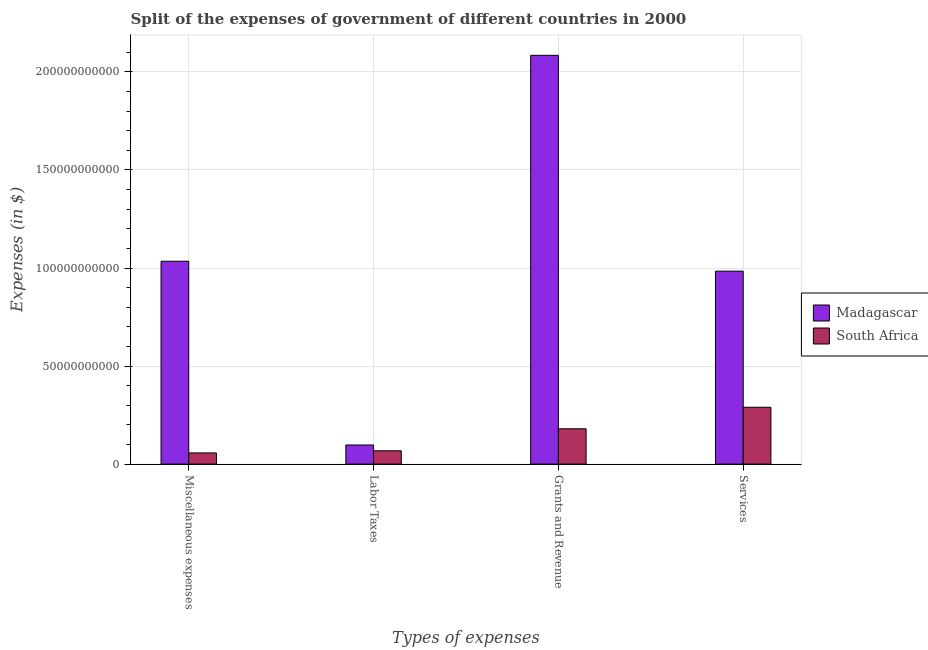How many different coloured bars are there?
Your response must be concise. 2. How many groups of bars are there?
Provide a succinct answer. 4. Are the number of bars on each tick of the X-axis equal?
Offer a terse response. Yes. What is the label of the 2nd group of bars from the left?
Give a very brief answer. Labor Taxes. What is the amount spent on labor taxes in Madagascar?
Your response must be concise. 9.76e+09. Across all countries, what is the maximum amount spent on labor taxes?
Your answer should be compact. 9.76e+09. Across all countries, what is the minimum amount spent on services?
Provide a succinct answer. 2.90e+1. In which country was the amount spent on grants and revenue maximum?
Ensure brevity in your answer.  Madagascar. In which country was the amount spent on labor taxes minimum?
Offer a terse response. South Africa. What is the total amount spent on grants and revenue in the graph?
Your answer should be very brief. 2.26e+11. What is the difference between the amount spent on grants and revenue in Madagascar and that in South Africa?
Make the answer very short. 1.90e+11. What is the difference between the amount spent on grants and revenue in Madagascar and the amount spent on services in South Africa?
Your answer should be very brief. 1.79e+11. What is the average amount spent on grants and revenue per country?
Offer a terse response. 1.13e+11. What is the difference between the amount spent on miscellaneous expenses and amount spent on services in Madagascar?
Your response must be concise. 5.06e+09. In how many countries, is the amount spent on services greater than 110000000000 $?
Make the answer very short. 0. What is the ratio of the amount spent on services in South Africa to that in Madagascar?
Your response must be concise. 0.29. Is the amount spent on services in South Africa less than that in Madagascar?
Your answer should be compact. Yes. Is the difference between the amount spent on services in Madagascar and South Africa greater than the difference between the amount spent on grants and revenue in Madagascar and South Africa?
Your response must be concise. No. What is the difference between the highest and the second highest amount spent on miscellaneous expenses?
Provide a succinct answer. 9.78e+1. What is the difference between the highest and the lowest amount spent on labor taxes?
Your answer should be compact. 2.96e+09. In how many countries, is the amount spent on services greater than the average amount spent on services taken over all countries?
Your response must be concise. 1. What does the 1st bar from the left in Labor Taxes represents?
Give a very brief answer. Madagascar. What does the 1st bar from the right in Services represents?
Offer a very short reply. South Africa. Is it the case that in every country, the sum of the amount spent on miscellaneous expenses and amount spent on labor taxes is greater than the amount spent on grants and revenue?
Ensure brevity in your answer.  No. How many bars are there?
Offer a very short reply. 8. What is the difference between two consecutive major ticks on the Y-axis?
Give a very brief answer. 5.00e+1. Are the values on the major ticks of Y-axis written in scientific E-notation?
Ensure brevity in your answer.  No. Does the graph contain any zero values?
Ensure brevity in your answer.  No. Does the graph contain grids?
Offer a terse response. Yes. Where does the legend appear in the graph?
Provide a succinct answer. Center right. How many legend labels are there?
Offer a terse response. 2. How are the legend labels stacked?
Give a very brief answer. Vertical. What is the title of the graph?
Provide a succinct answer. Split of the expenses of government of different countries in 2000. Does "Botswana" appear as one of the legend labels in the graph?
Provide a succinct answer. No. What is the label or title of the X-axis?
Make the answer very short. Types of expenses. What is the label or title of the Y-axis?
Provide a short and direct response. Expenses (in $). What is the Expenses (in $) in Madagascar in Miscellaneous expenses?
Keep it short and to the point. 1.03e+11. What is the Expenses (in $) of South Africa in Miscellaneous expenses?
Give a very brief answer. 5.70e+09. What is the Expenses (in $) in Madagascar in Labor Taxes?
Your answer should be very brief. 9.76e+09. What is the Expenses (in $) in South Africa in Labor Taxes?
Give a very brief answer. 6.80e+09. What is the Expenses (in $) in Madagascar in Grants and Revenue?
Make the answer very short. 2.08e+11. What is the Expenses (in $) of South Africa in Grants and Revenue?
Provide a short and direct response. 1.80e+1. What is the Expenses (in $) of Madagascar in Services?
Give a very brief answer. 9.84e+1. What is the Expenses (in $) in South Africa in Services?
Make the answer very short. 2.90e+1. Across all Types of expenses, what is the maximum Expenses (in $) of Madagascar?
Your answer should be compact. 2.08e+11. Across all Types of expenses, what is the maximum Expenses (in $) in South Africa?
Offer a terse response. 2.90e+1. Across all Types of expenses, what is the minimum Expenses (in $) of Madagascar?
Ensure brevity in your answer.  9.76e+09. Across all Types of expenses, what is the minimum Expenses (in $) of South Africa?
Give a very brief answer. 5.70e+09. What is the total Expenses (in $) of Madagascar in the graph?
Offer a terse response. 4.20e+11. What is the total Expenses (in $) in South Africa in the graph?
Ensure brevity in your answer.  5.95e+1. What is the difference between the Expenses (in $) of Madagascar in Miscellaneous expenses and that in Labor Taxes?
Your answer should be compact. 9.37e+1. What is the difference between the Expenses (in $) of South Africa in Miscellaneous expenses and that in Labor Taxes?
Offer a very short reply. -1.09e+09. What is the difference between the Expenses (in $) of Madagascar in Miscellaneous expenses and that in Grants and Revenue?
Keep it short and to the point. -1.05e+11. What is the difference between the Expenses (in $) of South Africa in Miscellaneous expenses and that in Grants and Revenue?
Provide a short and direct response. -1.23e+1. What is the difference between the Expenses (in $) of Madagascar in Miscellaneous expenses and that in Services?
Keep it short and to the point. 5.06e+09. What is the difference between the Expenses (in $) in South Africa in Miscellaneous expenses and that in Services?
Make the answer very short. -2.33e+1. What is the difference between the Expenses (in $) in Madagascar in Labor Taxes and that in Grants and Revenue?
Give a very brief answer. -1.99e+11. What is the difference between the Expenses (in $) in South Africa in Labor Taxes and that in Grants and Revenue?
Offer a very short reply. -1.12e+1. What is the difference between the Expenses (in $) in Madagascar in Labor Taxes and that in Services?
Provide a succinct answer. -8.86e+1. What is the difference between the Expenses (in $) of South Africa in Labor Taxes and that in Services?
Your response must be concise. -2.22e+1. What is the difference between the Expenses (in $) in Madagascar in Grants and Revenue and that in Services?
Provide a succinct answer. 1.10e+11. What is the difference between the Expenses (in $) in South Africa in Grants and Revenue and that in Services?
Keep it short and to the point. -1.10e+1. What is the difference between the Expenses (in $) in Madagascar in Miscellaneous expenses and the Expenses (in $) in South Africa in Labor Taxes?
Make the answer very short. 9.67e+1. What is the difference between the Expenses (in $) in Madagascar in Miscellaneous expenses and the Expenses (in $) in South Africa in Grants and Revenue?
Provide a short and direct response. 8.54e+1. What is the difference between the Expenses (in $) in Madagascar in Miscellaneous expenses and the Expenses (in $) in South Africa in Services?
Provide a short and direct response. 7.45e+1. What is the difference between the Expenses (in $) of Madagascar in Labor Taxes and the Expenses (in $) of South Africa in Grants and Revenue?
Offer a very short reply. -8.26e+09. What is the difference between the Expenses (in $) of Madagascar in Labor Taxes and the Expenses (in $) of South Africa in Services?
Your response must be concise. -1.92e+1. What is the difference between the Expenses (in $) of Madagascar in Grants and Revenue and the Expenses (in $) of South Africa in Services?
Give a very brief answer. 1.79e+11. What is the average Expenses (in $) of Madagascar per Types of expenses?
Ensure brevity in your answer.  1.05e+11. What is the average Expenses (in $) of South Africa per Types of expenses?
Your answer should be compact. 1.49e+1. What is the difference between the Expenses (in $) in Madagascar and Expenses (in $) in South Africa in Miscellaneous expenses?
Keep it short and to the point. 9.78e+1. What is the difference between the Expenses (in $) in Madagascar and Expenses (in $) in South Africa in Labor Taxes?
Keep it short and to the point. 2.96e+09. What is the difference between the Expenses (in $) of Madagascar and Expenses (in $) of South Africa in Grants and Revenue?
Offer a very short reply. 1.90e+11. What is the difference between the Expenses (in $) in Madagascar and Expenses (in $) in South Africa in Services?
Give a very brief answer. 6.94e+1. What is the ratio of the Expenses (in $) of Madagascar in Miscellaneous expenses to that in Labor Taxes?
Ensure brevity in your answer.  10.6. What is the ratio of the Expenses (in $) in South Africa in Miscellaneous expenses to that in Labor Taxes?
Make the answer very short. 0.84. What is the ratio of the Expenses (in $) of Madagascar in Miscellaneous expenses to that in Grants and Revenue?
Offer a terse response. 0.5. What is the ratio of the Expenses (in $) of South Africa in Miscellaneous expenses to that in Grants and Revenue?
Keep it short and to the point. 0.32. What is the ratio of the Expenses (in $) in Madagascar in Miscellaneous expenses to that in Services?
Provide a short and direct response. 1.05. What is the ratio of the Expenses (in $) in South Africa in Miscellaneous expenses to that in Services?
Offer a very short reply. 0.2. What is the ratio of the Expenses (in $) of Madagascar in Labor Taxes to that in Grants and Revenue?
Offer a terse response. 0.05. What is the ratio of the Expenses (in $) in South Africa in Labor Taxes to that in Grants and Revenue?
Make the answer very short. 0.38. What is the ratio of the Expenses (in $) in Madagascar in Labor Taxes to that in Services?
Keep it short and to the point. 0.1. What is the ratio of the Expenses (in $) in South Africa in Labor Taxes to that in Services?
Provide a short and direct response. 0.23. What is the ratio of the Expenses (in $) in Madagascar in Grants and Revenue to that in Services?
Provide a short and direct response. 2.12. What is the ratio of the Expenses (in $) of South Africa in Grants and Revenue to that in Services?
Offer a very short reply. 0.62. What is the difference between the highest and the second highest Expenses (in $) in Madagascar?
Give a very brief answer. 1.05e+11. What is the difference between the highest and the second highest Expenses (in $) of South Africa?
Ensure brevity in your answer.  1.10e+1. What is the difference between the highest and the lowest Expenses (in $) of Madagascar?
Provide a succinct answer. 1.99e+11. What is the difference between the highest and the lowest Expenses (in $) in South Africa?
Provide a short and direct response. 2.33e+1. 